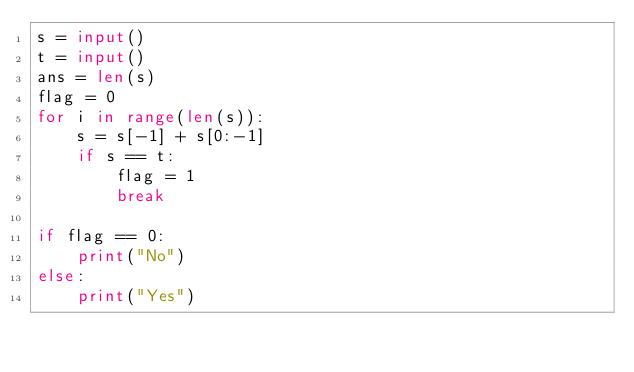Convert code to text. <code><loc_0><loc_0><loc_500><loc_500><_Python_>s = input()
t = input()
ans = len(s)
flag = 0
for i in range(len(s)):
    s = s[-1] + s[0:-1]
    if s == t:
        flag = 1
        break

if flag == 0:
    print("No")
else:
    print("Yes")</code> 